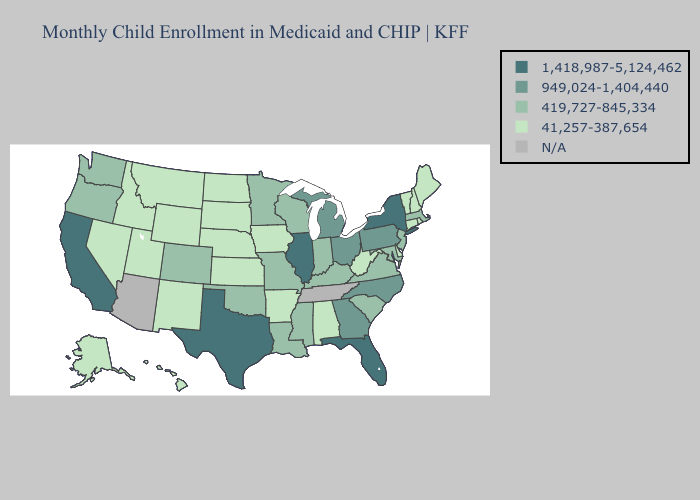What is the value of Idaho?
Be succinct. 41,257-387,654. Does Pennsylvania have the lowest value in the Northeast?
Short answer required. No. Among the states that border Georgia , which have the highest value?
Be succinct. Florida. Among the states that border Rhode Island , which have the lowest value?
Write a very short answer. Connecticut. Name the states that have a value in the range 41,257-387,654?
Write a very short answer. Alabama, Alaska, Arkansas, Connecticut, Delaware, Hawaii, Idaho, Iowa, Kansas, Maine, Montana, Nebraska, Nevada, New Hampshire, New Mexico, North Dakota, Rhode Island, South Dakota, Utah, Vermont, West Virginia, Wyoming. What is the value of South Dakota?
Give a very brief answer. 41,257-387,654. What is the lowest value in the USA?
Be succinct. 41,257-387,654. Name the states that have a value in the range N/A?
Quick response, please. Arizona, Tennessee. Name the states that have a value in the range 41,257-387,654?
Quick response, please. Alabama, Alaska, Arkansas, Connecticut, Delaware, Hawaii, Idaho, Iowa, Kansas, Maine, Montana, Nebraska, Nevada, New Hampshire, New Mexico, North Dakota, Rhode Island, South Dakota, Utah, Vermont, West Virginia, Wyoming. Which states have the highest value in the USA?
Quick response, please. California, Florida, Illinois, New York, Texas. What is the value of New Mexico?
Be succinct. 41,257-387,654. Which states have the lowest value in the West?
Write a very short answer. Alaska, Hawaii, Idaho, Montana, Nevada, New Mexico, Utah, Wyoming. Does the first symbol in the legend represent the smallest category?
Write a very short answer. No. 